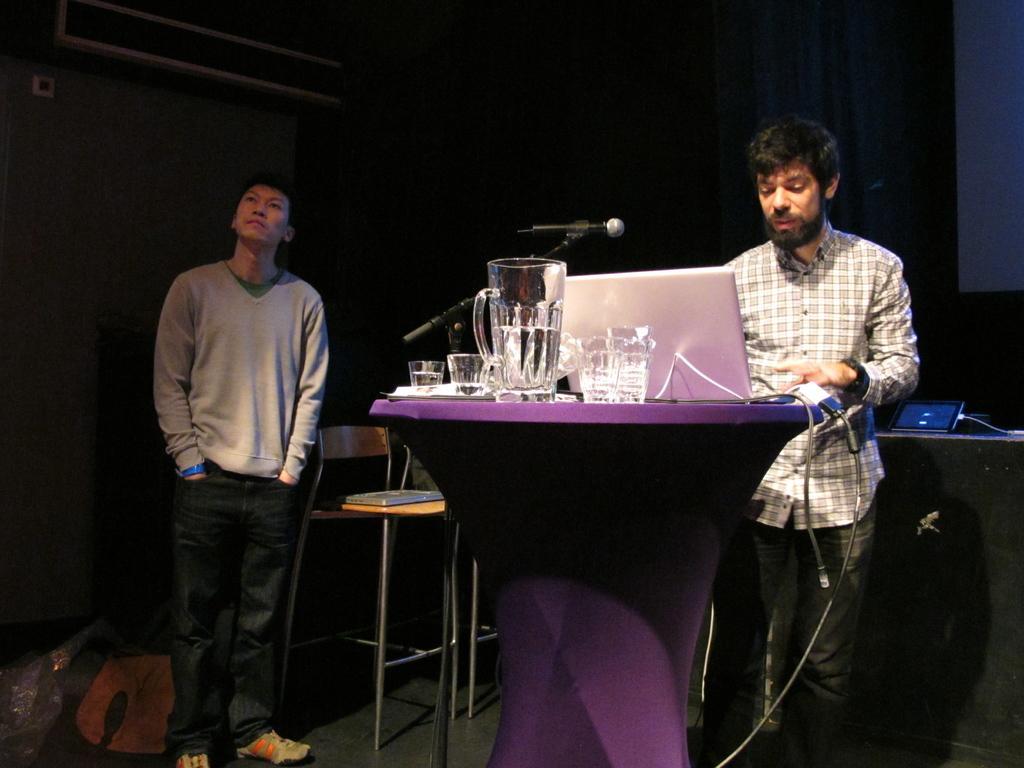Can you describe this image briefly? The person in the right is operating a laptop which is on the table and there are glass jars and glasses on it and there is a mic beside him and there is another person standing in the left corner. 